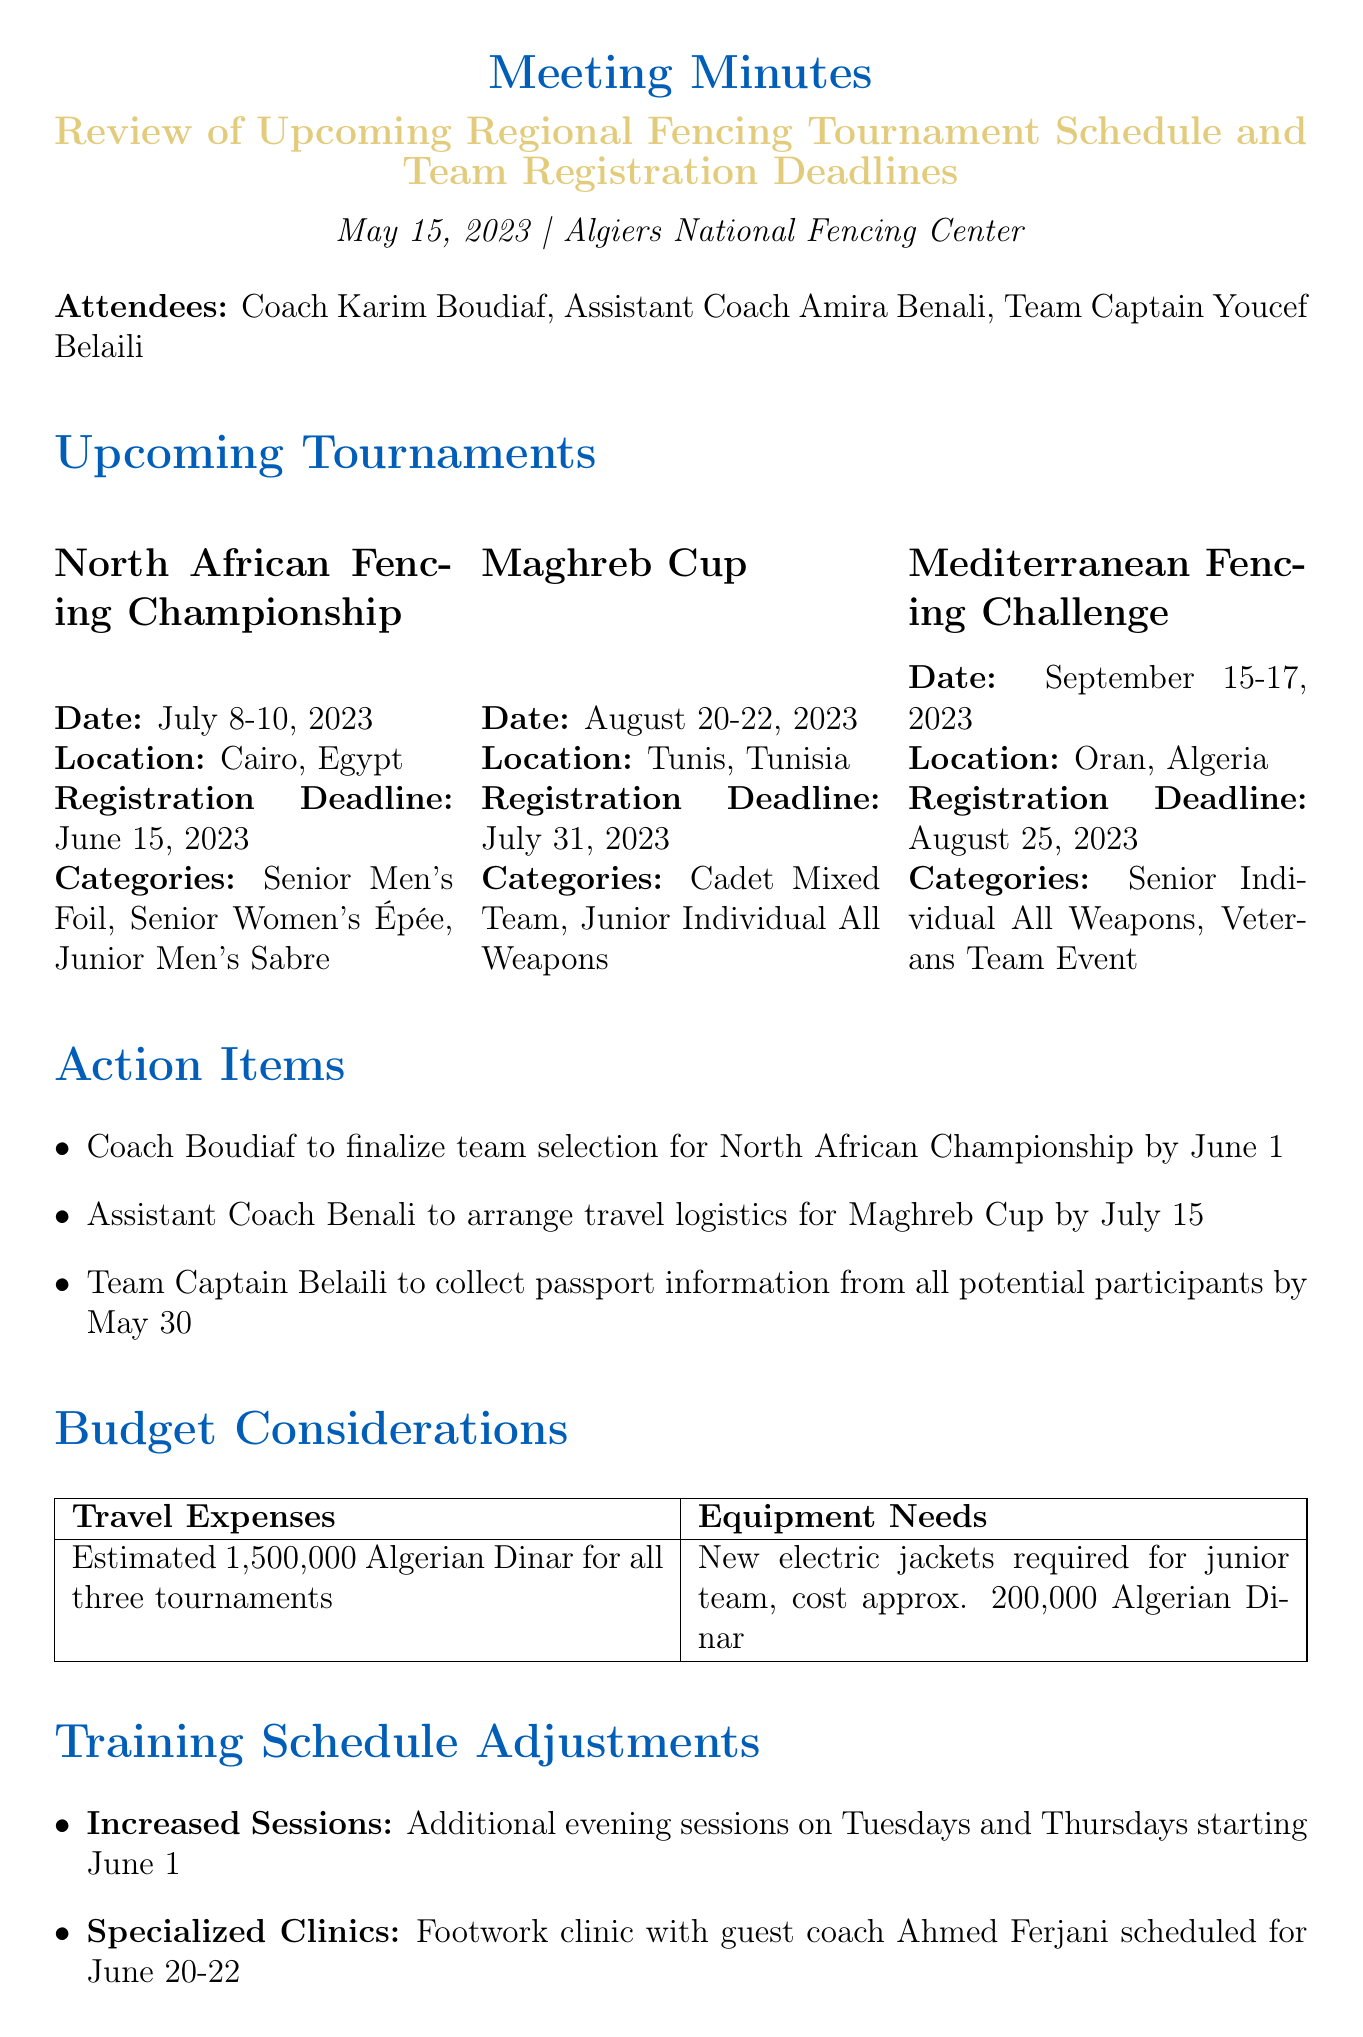what are the dates for the North African Fencing Championship? The document states that the North African Fencing Championship will take place from July 8-10, 2023.
Answer: July 8-10, 2023 what is the registration deadline for the Maghreb Cup? According to the meeting minutes, the registration deadline for the Maghreb Cup is July 31, 2023.
Answer: July 31, 2023 who is responsible for collecting passport information from participants? The meeting minutes indicate that Team Captain Youcef Belaili is responsible for collecting passport information.
Answer: Youcef Belaili how much is estimated for travel expenses for all three tournaments? The document mentions that the estimated travel expenses for all three tournaments are 1,500,000 Algerian Dinar.
Answer: 1,500,000 Algerian Dinar what additional sessions will be scheduled starting June 1? The meeting notes specify that additional evening sessions will be scheduled on Tuesdays and Thursdays starting June 1.
Answer: Additional evening sessions on Tuesdays and Thursdays what clinic is scheduled for June 20-22? The document states that a footwork clinic with guest coach Ahmed Ferjani is scheduled for June 20-22.
Answer: Footwork clinic with guest coach Ahmed Ferjani how many eligible categories are listed for the North African Fencing Championship? The document lists three eligible categories for the North African Fencing Championship.
Answer: Three what equipment is needed for the junior team? The meeting minutes specify that new electric jackets are required for the junior team.
Answer: New electric jackets who will arrange travel logistics for the Maghreb Cup? Assistant Coach Amira Benali is tasked with arranging travel logistics for the Maghreb Cup.
Answer: Amira Benali 